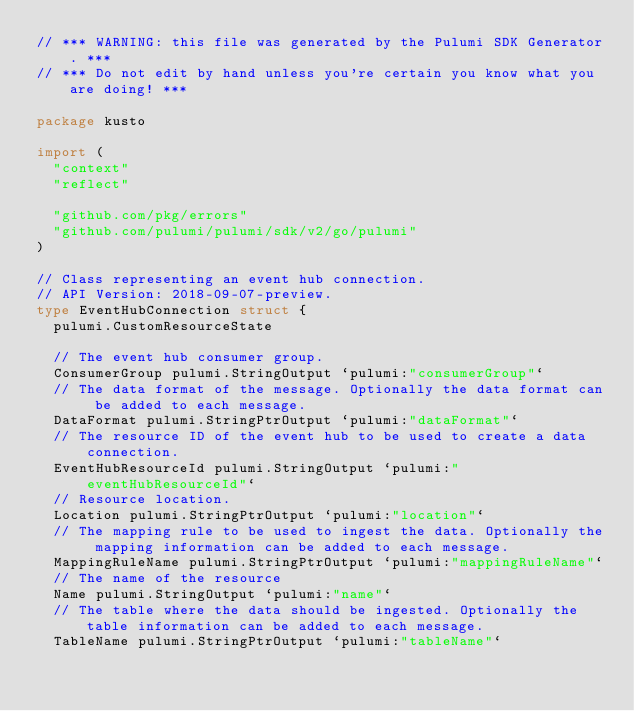<code> <loc_0><loc_0><loc_500><loc_500><_Go_>// *** WARNING: this file was generated by the Pulumi SDK Generator. ***
// *** Do not edit by hand unless you're certain you know what you are doing! ***

package kusto

import (
	"context"
	"reflect"

	"github.com/pkg/errors"
	"github.com/pulumi/pulumi/sdk/v2/go/pulumi"
)

// Class representing an event hub connection.
// API Version: 2018-09-07-preview.
type EventHubConnection struct {
	pulumi.CustomResourceState

	// The event hub consumer group.
	ConsumerGroup pulumi.StringOutput `pulumi:"consumerGroup"`
	// The data format of the message. Optionally the data format can be added to each message.
	DataFormat pulumi.StringPtrOutput `pulumi:"dataFormat"`
	// The resource ID of the event hub to be used to create a data connection.
	EventHubResourceId pulumi.StringOutput `pulumi:"eventHubResourceId"`
	// Resource location.
	Location pulumi.StringPtrOutput `pulumi:"location"`
	// The mapping rule to be used to ingest the data. Optionally the mapping information can be added to each message.
	MappingRuleName pulumi.StringPtrOutput `pulumi:"mappingRuleName"`
	// The name of the resource
	Name pulumi.StringOutput `pulumi:"name"`
	// The table where the data should be ingested. Optionally the table information can be added to each message.
	TableName pulumi.StringPtrOutput `pulumi:"tableName"`</code> 